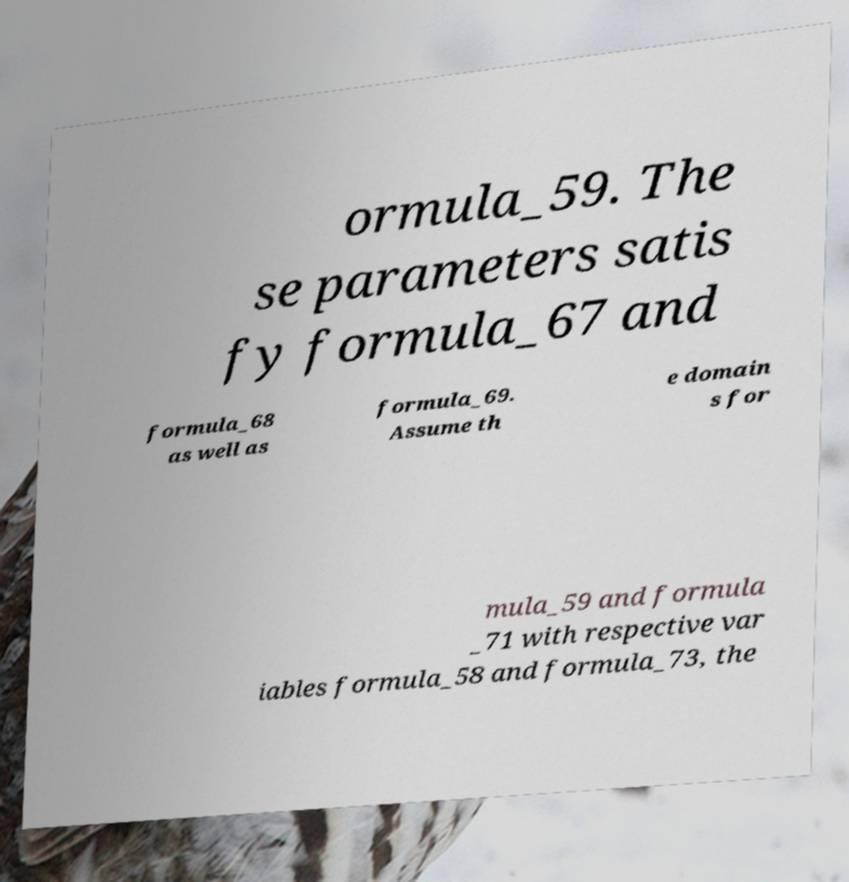Please read and relay the text visible in this image. What does it say? ormula_59. The se parameters satis fy formula_67 and formula_68 as well as formula_69. Assume th e domain s for mula_59 and formula _71 with respective var iables formula_58 and formula_73, the 